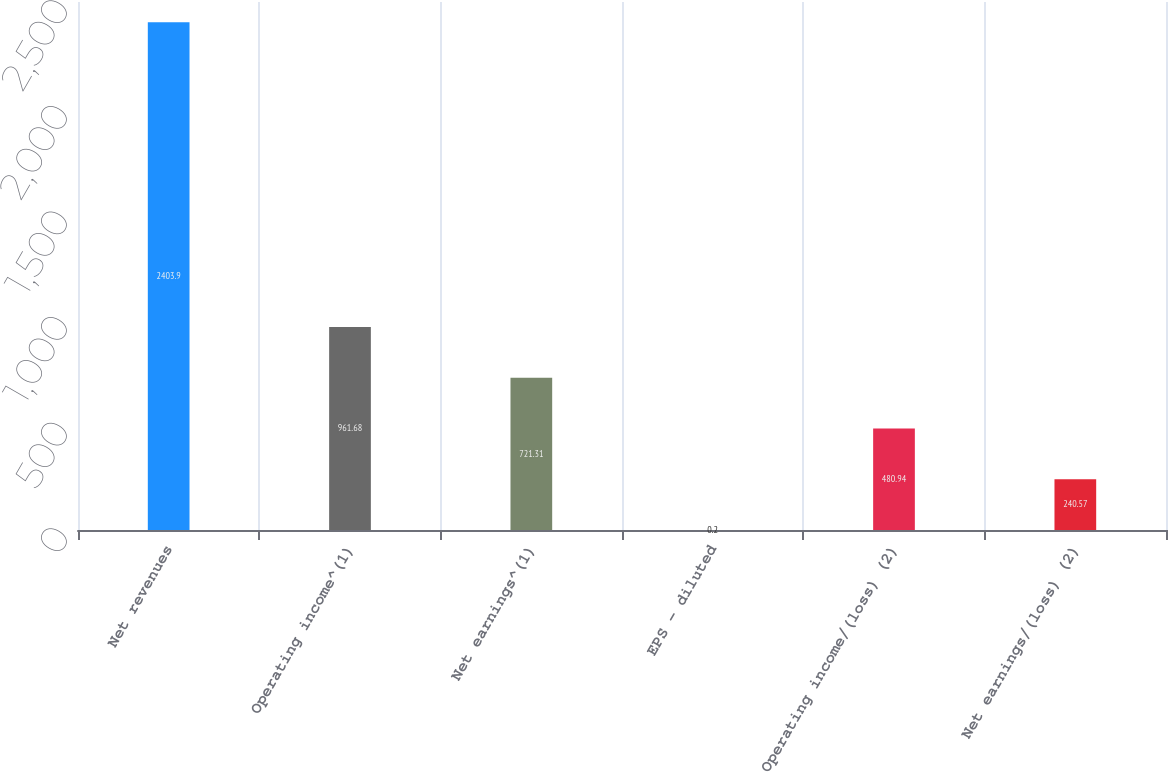Convert chart to OTSL. <chart><loc_0><loc_0><loc_500><loc_500><bar_chart><fcel>Net revenues<fcel>Operating income^(1)<fcel>Net earnings^(1)<fcel>EPS - diluted<fcel>Operating income/(loss) (2)<fcel>Net earnings/(loss) (2)<nl><fcel>2403.9<fcel>961.68<fcel>721.31<fcel>0.2<fcel>480.94<fcel>240.57<nl></chart> 